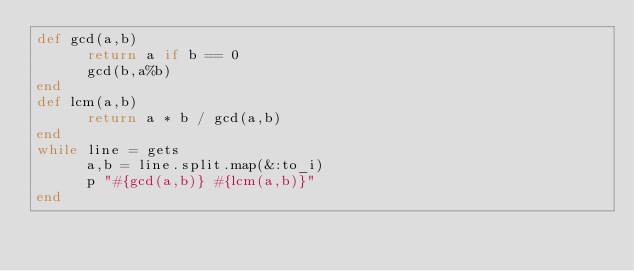<code> <loc_0><loc_0><loc_500><loc_500><_Ruby_>def gcd(a,b)
      return a if b == 0
      gcd(b,a%b)
end
def lcm(a,b)
      return a * b / gcd(a,b)
end
while line = gets
      a,b = line.split.map(&:to_i)
      p "#{gcd(a,b)} #{lcm(a,b)}"
end</code> 